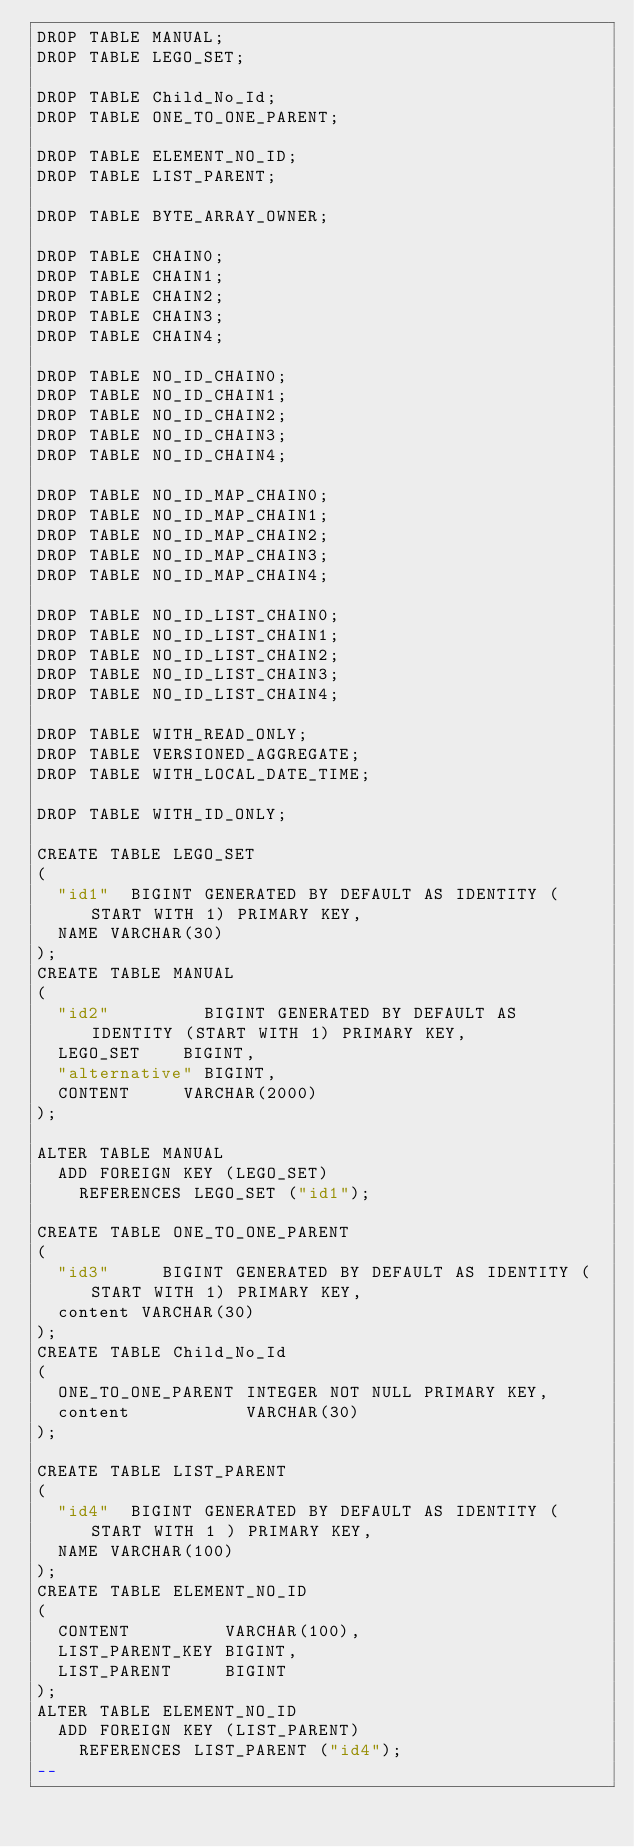<code> <loc_0><loc_0><loc_500><loc_500><_SQL_>DROP TABLE MANUAL;
DROP TABLE LEGO_SET;

DROP TABLE Child_No_Id;
DROP TABLE ONE_TO_ONE_PARENT;

DROP TABLE ELEMENT_NO_ID;
DROP TABLE LIST_PARENT;

DROP TABLE BYTE_ARRAY_OWNER;

DROP TABLE CHAIN0;
DROP TABLE CHAIN1;
DROP TABLE CHAIN2;
DROP TABLE CHAIN3;
DROP TABLE CHAIN4;

DROP TABLE NO_ID_CHAIN0;
DROP TABLE NO_ID_CHAIN1;
DROP TABLE NO_ID_CHAIN2;
DROP TABLE NO_ID_CHAIN3;
DROP TABLE NO_ID_CHAIN4;

DROP TABLE NO_ID_MAP_CHAIN0;
DROP TABLE NO_ID_MAP_CHAIN1;
DROP TABLE NO_ID_MAP_CHAIN2;
DROP TABLE NO_ID_MAP_CHAIN3;
DROP TABLE NO_ID_MAP_CHAIN4;

DROP TABLE NO_ID_LIST_CHAIN0;
DROP TABLE NO_ID_LIST_CHAIN1;
DROP TABLE NO_ID_LIST_CHAIN2;
DROP TABLE NO_ID_LIST_CHAIN3;
DROP TABLE NO_ID_LIST_CHAIN4;

DROP TABLE WITH_READ_ONLY;
DROP TABLE VERSIONED_AGGREGATE;
DROP TABLE WITH_LOCAL_DATE_TIME;

DROP TABLE WITH_ID_ONLY;

CREATE TABLE LEGO_SET
(
  "id1"  BIGINT GENERATED BY DEFAULT AS IDENTITY (START WITH 1) PRIMARY KEY,
  NAME VARCHAR(30)
);
CREATE TABLE MANUAL
(
  "id2"         BIGINT GENERATED BY DEFAULT AS IDENTITY (START WITH 1) PRIMARY KEY,
  LEGO_SET    BIGINT,
  "alternative" BIGINT,
  CONTENT     VARCHAR(2000)
);

ALTER TABLE MANUAL
  ADD FOREIGN KEY (LEGO_SET)
    REFERENCES LEGO_SET ("id1");

CREATE TABLE ONE_TO_ONE_PARENT
(
  "id3"     BIGINT GENERATED BY DEFAULT AS IDENTITY (START WITH 1) PRIMARY KEY,
  content VARCHAR(30)
);
CREATE TABLE Child_No_Id
(
  ONE_TO_ONE_PARENT INTEGER NOT NULL PRIMARY KEY,
  content           VARCHAR(30)
);

CREATE TABLE LIST_PARENT
(
  "id4"  BIGINT GENERATED BY DEFAULT AS IDENTITY ( START WITH 1 ) PRIMARY KEY,
  NAME VARCHAR(100)
);
CREATE TABLE ELEMENT_NO_ID
(
  CONTENT         VARCHAR(100),
  LIST_PARENT_KEY BIGINT,
  LIST_PARENT     BIGINT
);
ALTER TABLE ELEMENT_NO_ID
  ADD FOREIGN KEY (LIST_PARENT)
    REFERENCES LIST_PARENT ("id4");
--</code> 